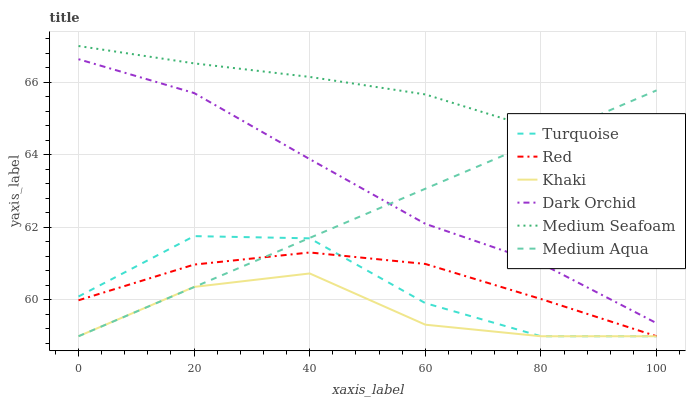Does Khaki have the minimum area under the curve?
Answer yes or no. Yes. Does Medium Seafoam have the maximum area under the curve?
Answer yes or no. Yes. Does Dark Orchid have the minimum area under the curve?
Answer yes or no. No. Does Dark Orchid have the maximum area under the curve?
Answer yes or no. No. Is Medium Aqua the smoothest?
Answer yes or no. Yes. Is Turquoise the roughest?
Answer yes or no. Yes. Is Khaki the smoothest?
Answer yes or no. No. Is Khaki the roughest?
Answer yes or no. No. Does Dark Orchid have the lowest value?
Answer yes or no. No. Does Dark Orchid have the highest value?
Answer yes or no. No. Is Khaki less than Medium Seafoam?
Answer yes or no. Yes. Is Dark Orchid greater than Red?
Answer yes or no. Yes. Does Khaki intersect Medium Seafoam?
Answer yes or no. No. 